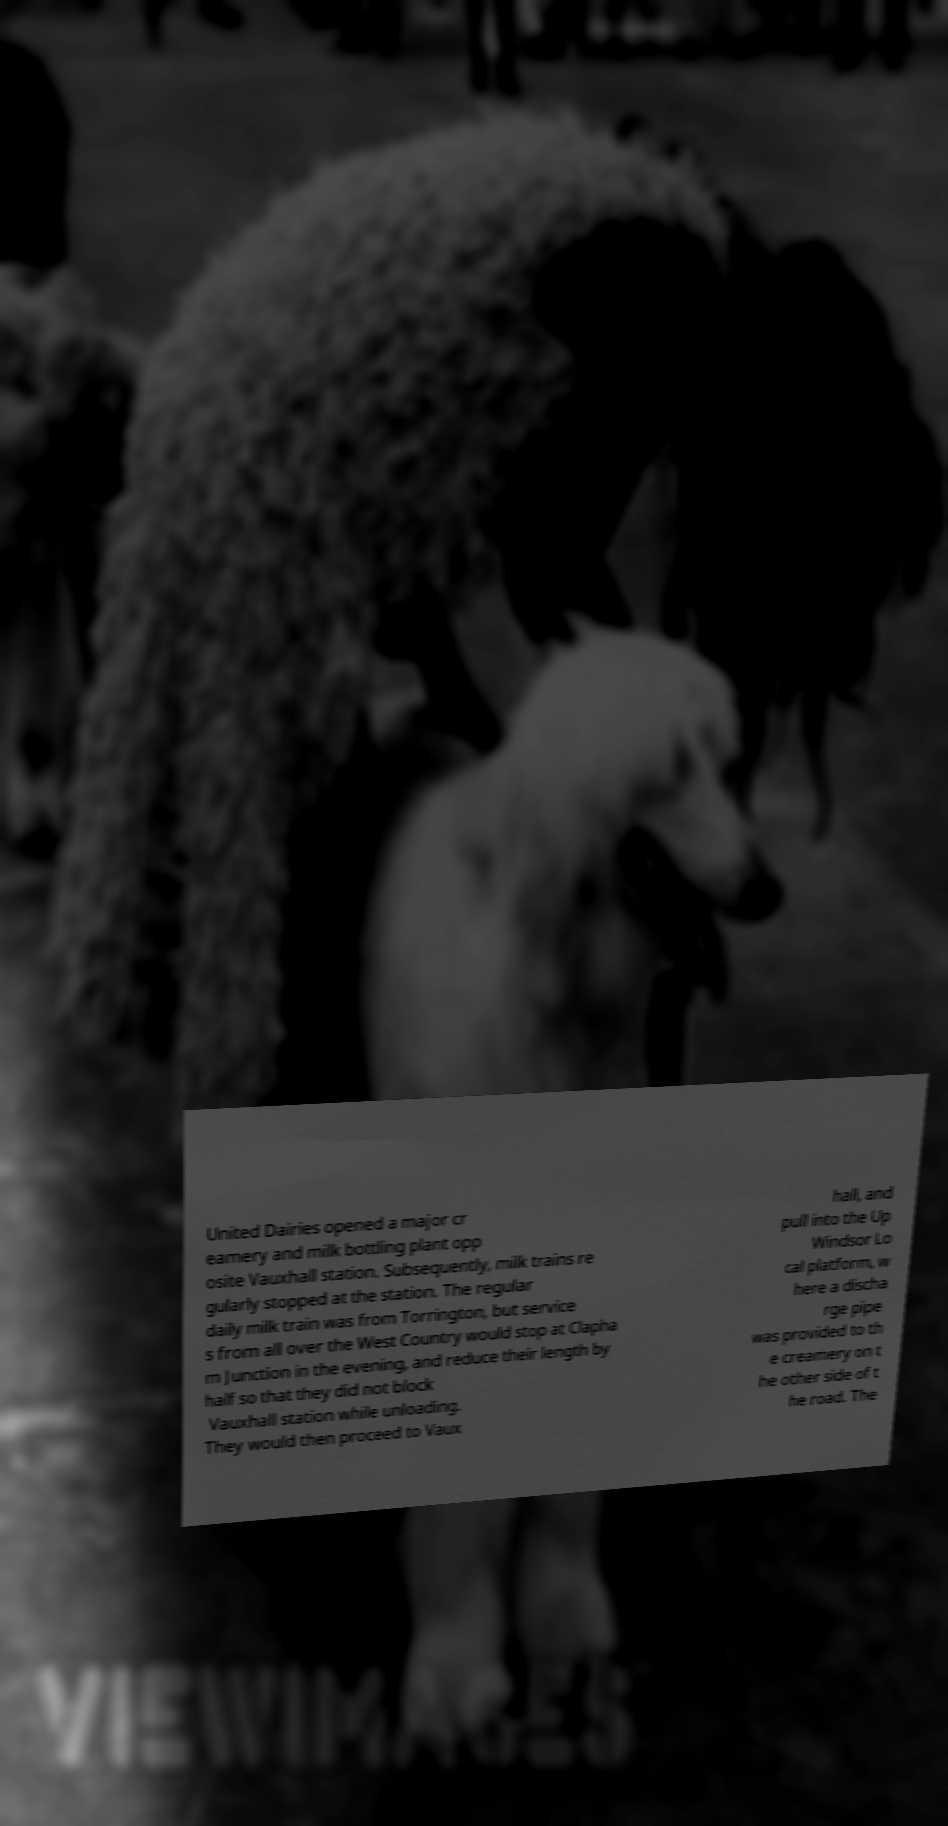There's text embedded in this image that I need extracted. Can you transcribe it verbatim? United Dairies opened a major cr eamery and milk bottling plant opp osite Vauxhall station. Subsequently, milk trains re gularly stopped at the station. The regular daily milk train was from Torrington, but service s from all over the West Country would stop at Clapha m Junction in the evening, and reduce their length by half so that they did not block Vauxhall station while unloading. They would then proceed to Vaux hall, and pull into the Up Windsor Lo cal platform, w here a discha rge pipe was provided to th e creamery on t he other side of t he road. The 